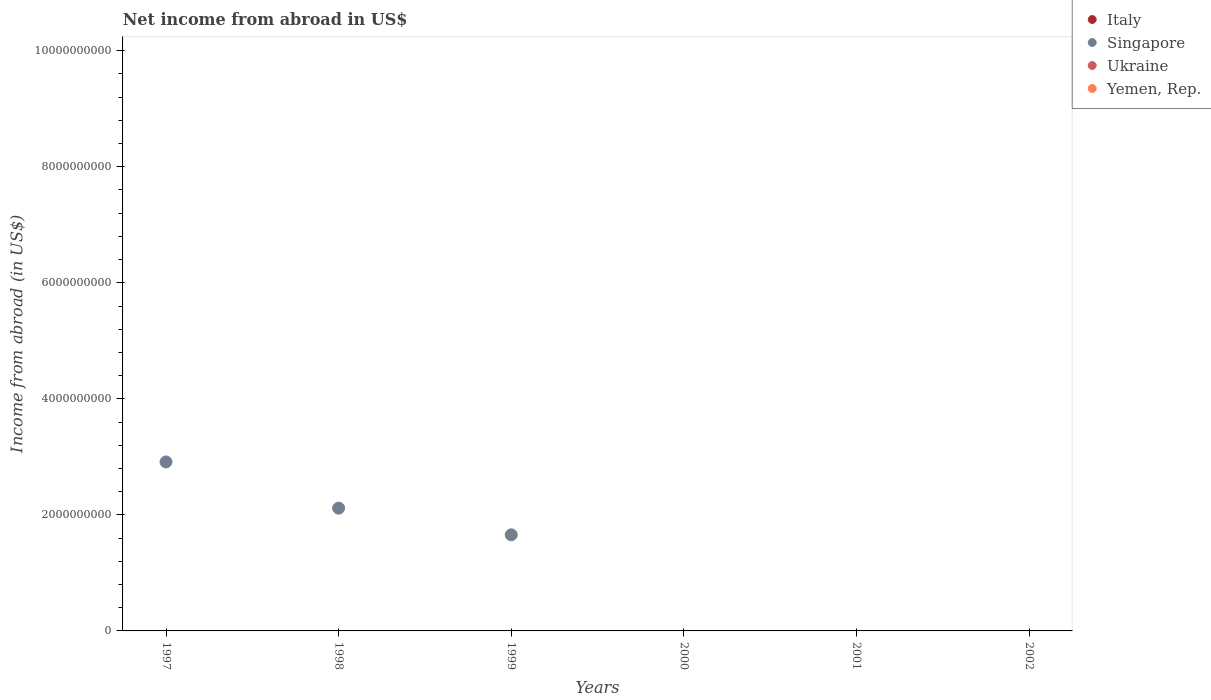What is the net income from abroad in Singapore in 1997?
Your answer should be very brief. 2.91e+09. Across all years, what is the maximum net income from abroad in Singapore?
Your response must be concise. 2.91e+09. Across all years, what is the minimum net income from abroad in Singapore?
Make the answer very short. 0. What is the total net income from abroad in Yemen, Rep. in the graph?
Ensure brevity in your answer.  0. What is the difference between the net income from abroad in Singapore in 1997 and that in 1998?
Give a very brief answer. 7.96e+08. What is the difference between the net income from abroad in Italy in 1998 and the net income from abroad in Yemen, Rep. in 1999?
Provide a short and direct response. 0. What is the average net income from abroad in Singapore per year?
Ensure brevity in your answer.  1.11e+09. In how many years, is the net income from abroad in Italy greater than 4800000000 US$?
Keep it short and to the point. 0. What is the difference between the highest and the second highest net income from abroad in Singapore?
Your answer should be compact. 7.96e+08. What is the difference between the highest and the lowest net income from abroad in Singapore?
Offer a terse response. 2.91e+09. Is it the case that in every year, the sum of the net income from abroad in Singapore and net income from abroad in Italy  is greater than the sum of net income from abroad in Ukraine and net income from abroad in Yemen, Rep.?
Provide a short and direct response. No. Is it the case that in every year, the sum of the net income from abroad in Italy and net income from abroad in Singapore  is greater than the net income from abroad in Yemen, Rep.?
Your answer should be compact. No. Is the net income from abroad in Ukraine strictly less than the net income from abroad in Italy over the years?
Provide a short and direct response. No. How many years are there in the graph?
Your answer should be very brief. 6. Are the values on the major ticks of Y-axis written in scientific E-notation?
Offer a terse response. No. Does the graph contain any zero values?
Offer a very short reply. Yes. Where does the legend appear in the graph?
Your answer should be compact. Top right. How are the legend labels stacked?
Offer a very short reply. Vertical. What is the title of the graph?
Provide a succinct answer. Net income from abroad in US$. What is the label or title of the X-axis?
Your answer should be compact. Years. What is the label or title of the Y-axis?
Give a very brief answer. Income from abroad (in US$). What is the Income from abroad (in US$) of Italy in 1997?
Offer a very short reply. 0. What is the Income from abroad (in US$) of Singapore in 1997?
Make the answer very short. 2.91e+09. What is the Income from abroad (in US$) in Ukraine in 1997?
Offer a very short reply. 0. What is the Income from abroad (in US$) of Italy in 1998?
Keep it short and to the point. 0. What is the Income from abroad (in US$) of Singapore in 1998?
Provide a short and direct response. 2.12e+09. What is the Income from abroad (in US$) in Yemen, Rep. in 1998?
Your answer should be compact. 0. What is the Income from abroad (in US$) of Italy in 1999?
Ensure brevity in your answer.  0. What is the Income from abroad (in US$) in Singapore in 1999?
Offer a very short reply. 1.66e+09. What is the Income from abroad (in US$) in Yemen, Rep. in 1999?
Provide a succinct answer. 0. What is the Income from abroad (in US$) of Singapore in 2000?
Your response must be concise. 0. What is the Income from abroad (in US$) of Yemen, Rep. in 2001?
Offer a terse response. 0. What is the Income from abroad (in US$) in Italy in 2002?
Offer a very short reply. 0. What is the Income from abroad (in US$) in Singapore in 2002?
Provide a succinct answer. 0. What is the Income from abroad (in US$) in Ukraine in 2002?
Your response must be concise. 0. What is the Income from abroad (in US$) of Yemen, Rep. in 2002?
Your answer should be compact. 0. Across all years, what is the maximum Income from abroad (in US$) of Singapore?
Provide a succinct answer. 2.91e+09. Across all years, what is the minimum Income from abroad (in US$) in Singapore?
Make the answer very short. 0. What is the total Income from abroad (in US$) in Singapore in the graph?
Keep it short and to the point. 6.69e+09. What is the difference between the Income from abroad (in US$) in Singapore in 1997 and that in 1998?
Ensure brevity in your answer.  7.96e+08. What is the difference between the Income from abroad (in US$) of Singapore in 1997 and that in 1999?
Your answer should be compact. 1.26e+09. What is the difference between the Income from abroad (in US$) in Singapore in 1998 and that in 1999?
Make the answer very short. 4.60e+08. What is the average Income from abroad (in US$) of Singapore per year?
Provide a short and direct response. 1.11e+09. What is the average Income from abroad (in US$) of Ukraine per year?
Offer a very short reply. 0. What is the average Income from abroad (in US$) in Yemen, Rep. per year?
Provide a succinct answer. 0. What is the ratio of the Income from abroad (in US$) of Singapore in 1997 to that in 1998?
Offer a very short reply. 1.38. What is the ratio of the Income from abroad (in US$) in Singapore in 1997 to that in 1999?
Give a very brief answer. 1.76. What is the ratio of the Income from abroad (in US$) of Singapore in 1998 to that in 1999?
Make the answer very short. 1.28. What is the difference between the highest and the second highest Income from abroad (in US$) in Singapore?
Provide a short and direct response. 7.96e+08. What is the difference between the highest and the lowest Income from abroad (in US$) in Singapore?
Offer a very short reply. 2.91e+09. 